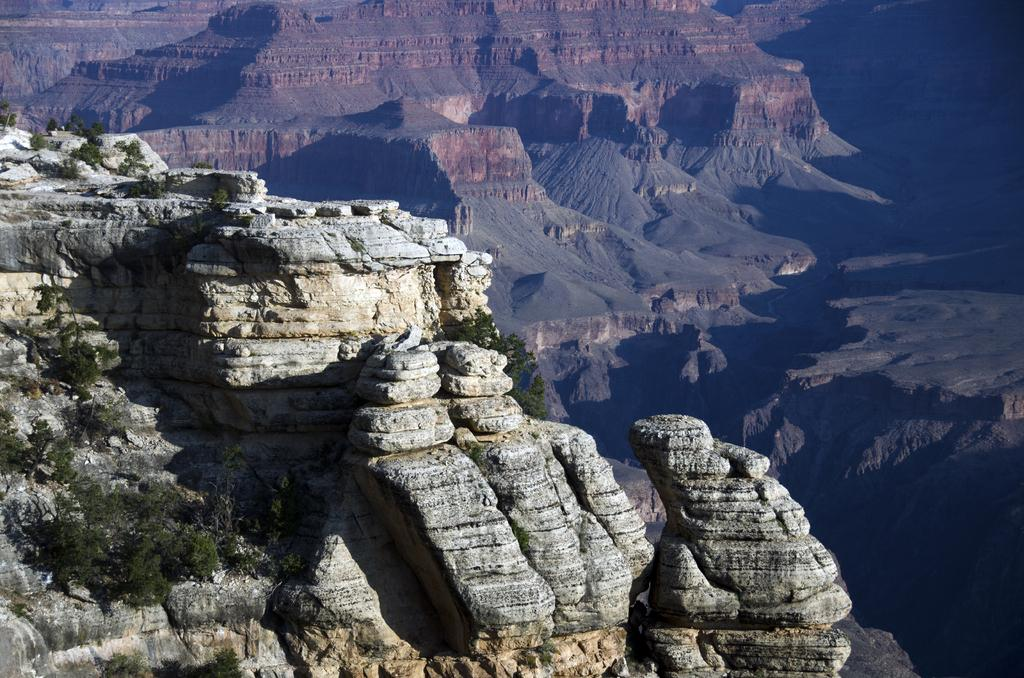What type of natural landscape can be seen in the image? There are mountains and trees in the image. Can you describe the mountains in the image? The mountains in the image are likely large, elevated landforms. What type of vegetation is present in the image? Trees are the type of vegetation present in the image. What type of yoke can be seen connecting the trees in the image? There is no yoke present in the image; it features mountains and trees. What sound can be heard coming from the mountains in the image? The image is a still picture, so no sound can be heard. 